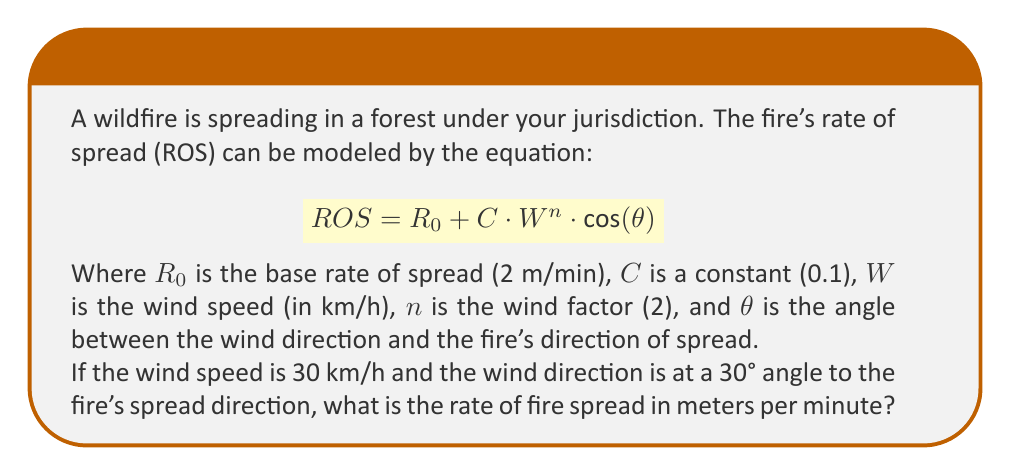Provide a solution to this math problem. Let's approach this step-by-step:

1) We're given the equation:
   $$ ROS = R_0 + C \cdot W^n \cdot \cos(\theta) $$

2) We know the following values:
   - $R_0 = 2$ m/min (base rate of spread)
   - $C = 0.1$ (constant)
   - $W = 30$ km/h (wind speed)
   - $n = 2$ (wind factor)
   - $\theta = 30°$ (angle between wind direction and fire spread)

3) Let's substitute these values into the equation:
   $$ ROS = 2 + 0.1 \cdot 30^2 \cdot \cos(30°) $$

4) First, let's calculate $30^2$:
   $$ 30^2 = 900 $$

5) Now, let's calculate $\cos(30°)$:
   $$ \cos(30°) = \frac{\sqrt{3}}{2} \approx 0.866 $$

6) Substituting these values:
   $$ ROS = 2 + 0.1 \cdot 900 \cdot 0.866 $$

7) Simplify:
   $$ ROS = 2 + 77.94 = 79.94 $$

Therefore, the rate of fire spread is approximately 79.94 meters per minute.
Answer: 79.94 m/min 